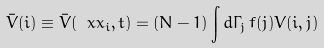<formula> <loc_0><loc_0><loc_500><loc_500>\bar { V } ( i ) \equiv \bar { V } ( \ x x _ { i } , t ) = ( N - 1 ) \int d \Gamma _ { j } \, f ( j ) V ( i , j )</formula> 